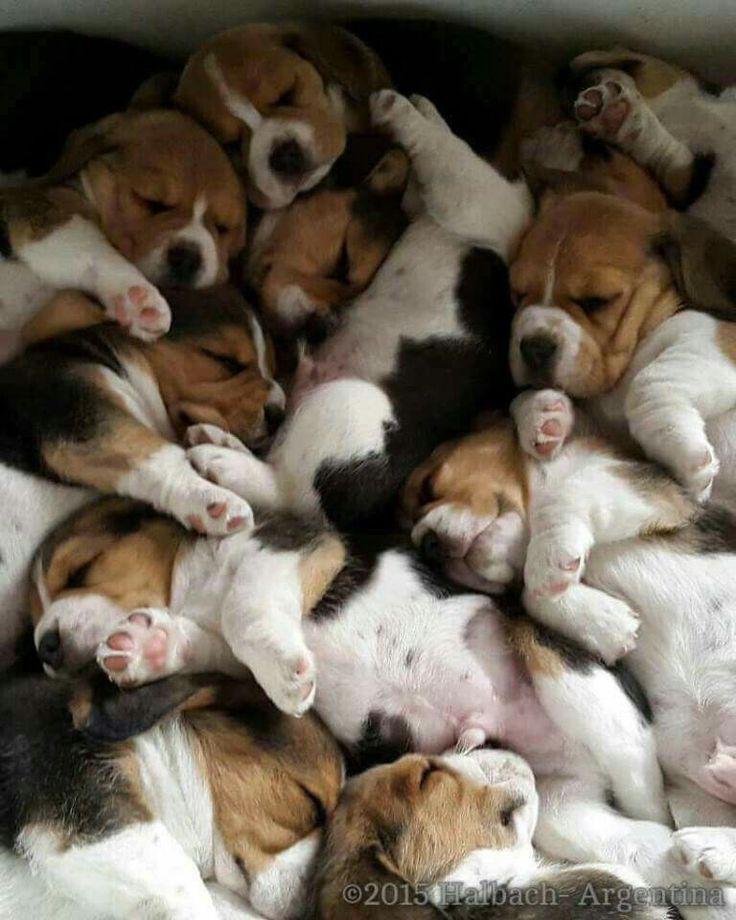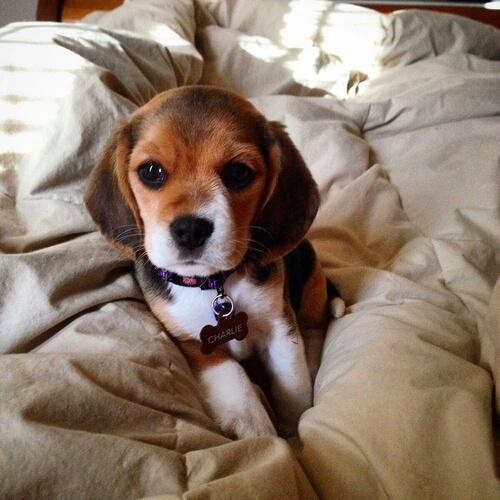The first image is the image on the left, the second image is the image on the right. Considering the images on both sides, is "In one of the images, there are more than three puppies." valid? Answer yes or no. Yes. The first image is the image on the left, the second image is the image on the right. Assess this claim about the two images: "There are at most three dogs.". Correct or not? Answer yes or no. No. 